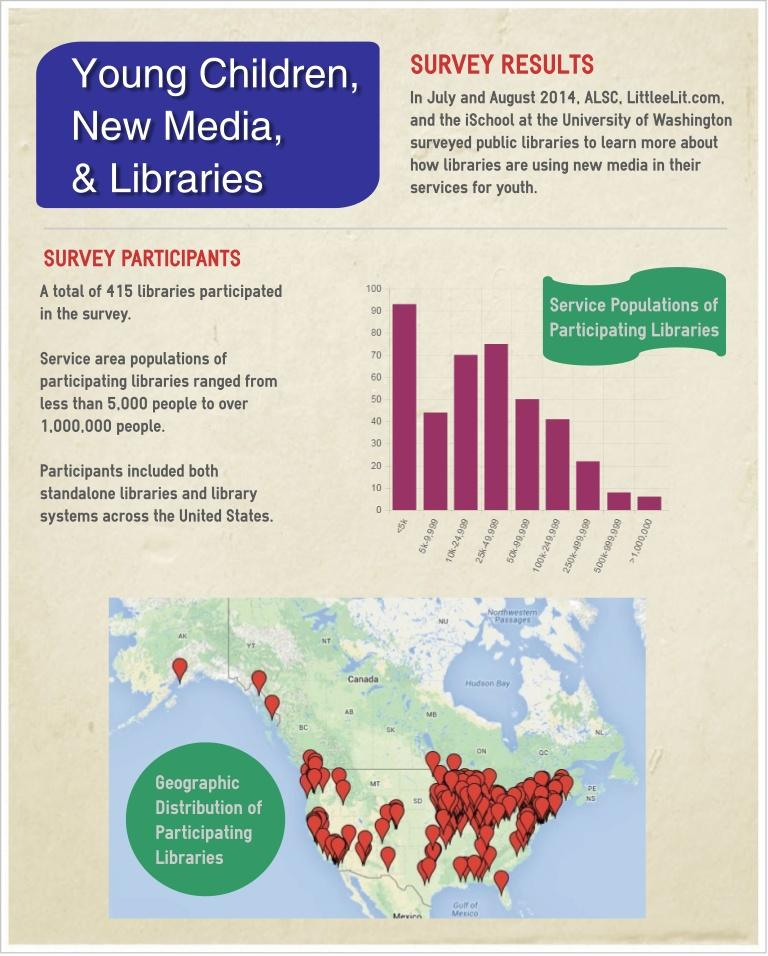Specify some key components in this picture. The library, which has achieved the third highest position in the survey, has a population of 10,000 to 24,999 individuals. The survey has higher participation rates in the East region of the United States. The library, which has achieved the second highest position in the survey, has a population of 25,000 to 49,999 individuals. 